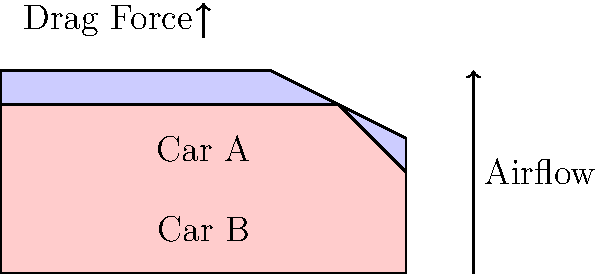Two sports car designs, Car A and Car B, are being analyzed for their aerodynamic performance in the wind tunnel. The simplified 2D profiles of both cars are shown above. If the drag coefficient ($C_d$) for Car A is 0.35 and for Car B is 0.30, and both cars have the same frontal area of 2.2 m², which car will experience a higher drag force at a speed of 200 km/h? Assume air density ($\rho$) is 1.225 kg/m³. Use the drag force equation: $F_d = \frac{1}{2} \rho v^2 C_d A$. To determine which car experiences a higher drag force, we need to calculate the drag force for each car using the given equation and compare the results.

Given:
- Air density ($\rho$) = 1.225 kg/m³
- Speed (v) = 200 km/h = 55.56 m/s (converted to m/s)
- Frontal area (A) = 2.2 m²
- Drag coefficient ($C_d$) for Car A = 0.35
- Drag coefficient ($C_d$) for Car B = 0.30

Step 1: Calculate drag force for Car A
$F_{d_A} = \frac{1}{2} \times 1.225 \times 55.56^2 \times 0.35 \times 2.2$
$F_{d_A} = 580.24 \text{ N}$

Step 2: Calculate drag force for Car B
$F_{d_B} = \frac{1}{2} \times 1.225 \times 55.56^2 \times 0.30 \times 2.2$
$F_{d_B} = 497.35 \text{ N}$

Step 3: Compare the results
Car A experiences a higher drag force (580.24 N) compared to Car B (497.35 N).
Answer: Car A experiences higher drag force. 